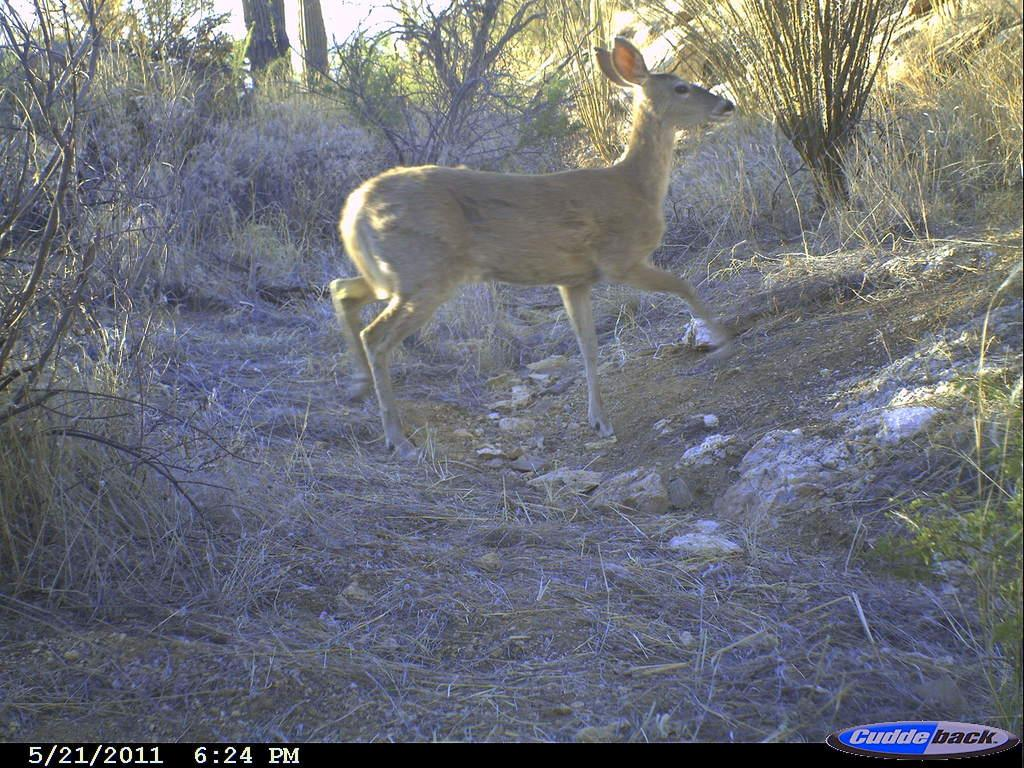What animal can be seen in the image? There is a deer in the image. What type of terrain is the deer walking on? The deer is walking on dry grassland. What can be seen in the background of the image? There are plants in the background of the image. How many boys are playing with toys inside the tent in the image? There are no boys, toys, or tents present in the image; it features a deer walking on dry grassland with plants in the background. 